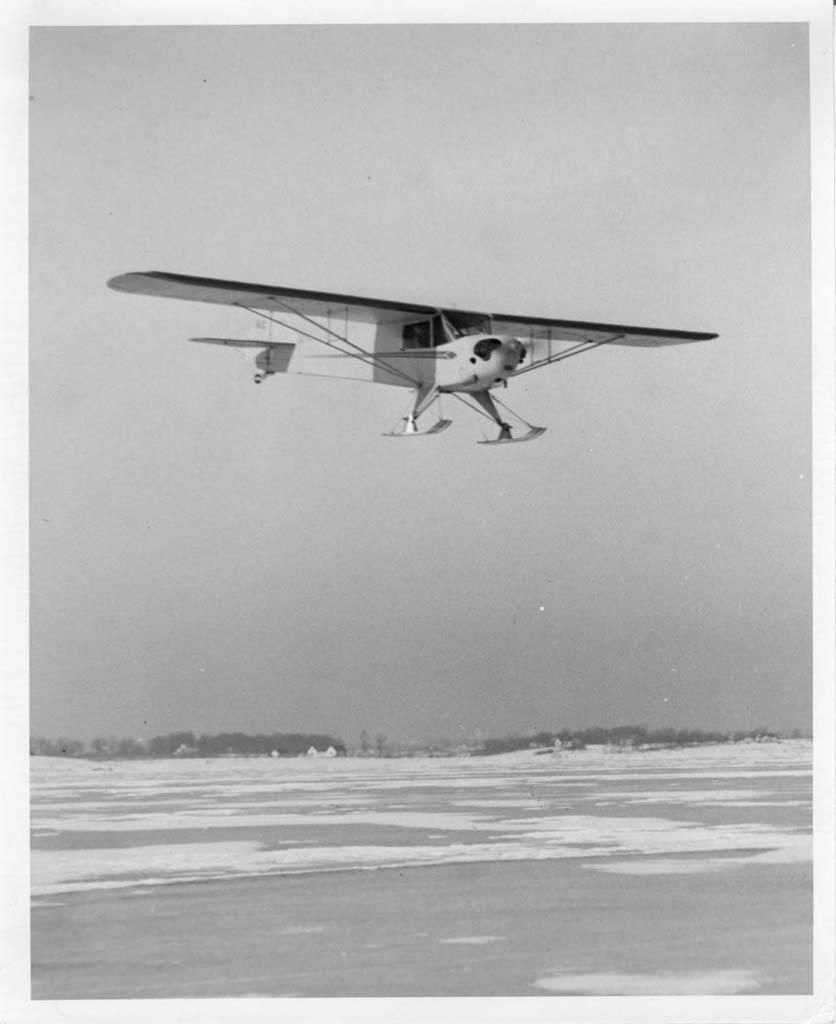Can you describe this image briefly? In this image we can black and white picture of an airplane flying in the sky. In the background, we can see a group of trees and the water. 